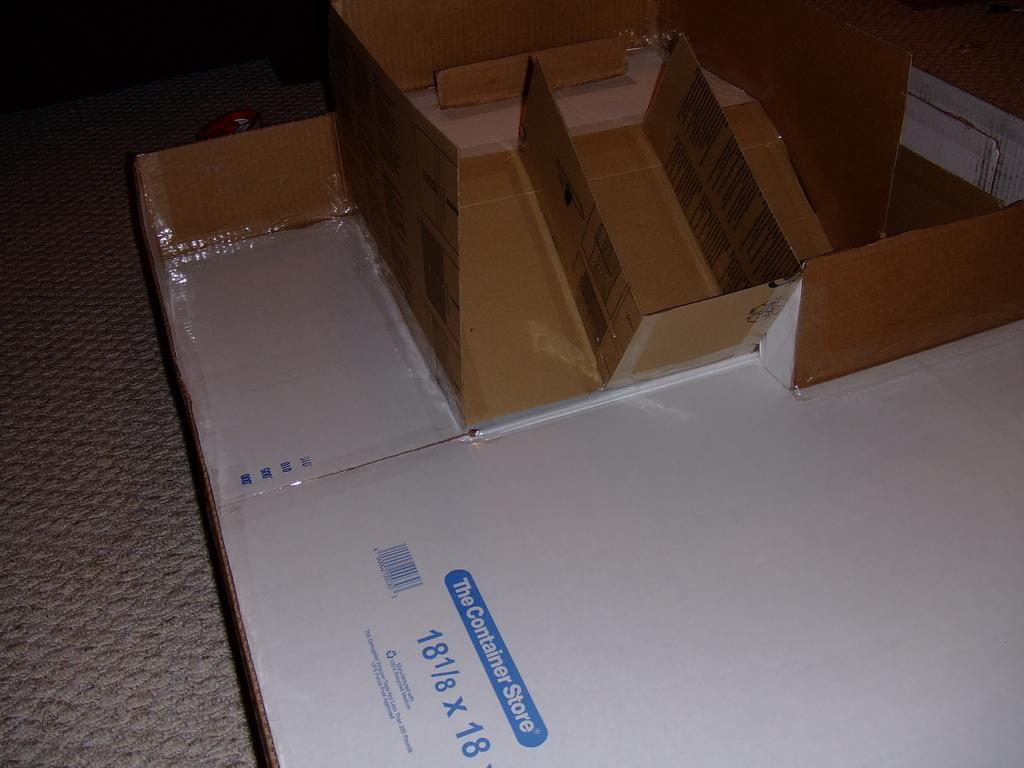<image>
Create a compact narrative representing the image presented. a box that is flattened from the container store 